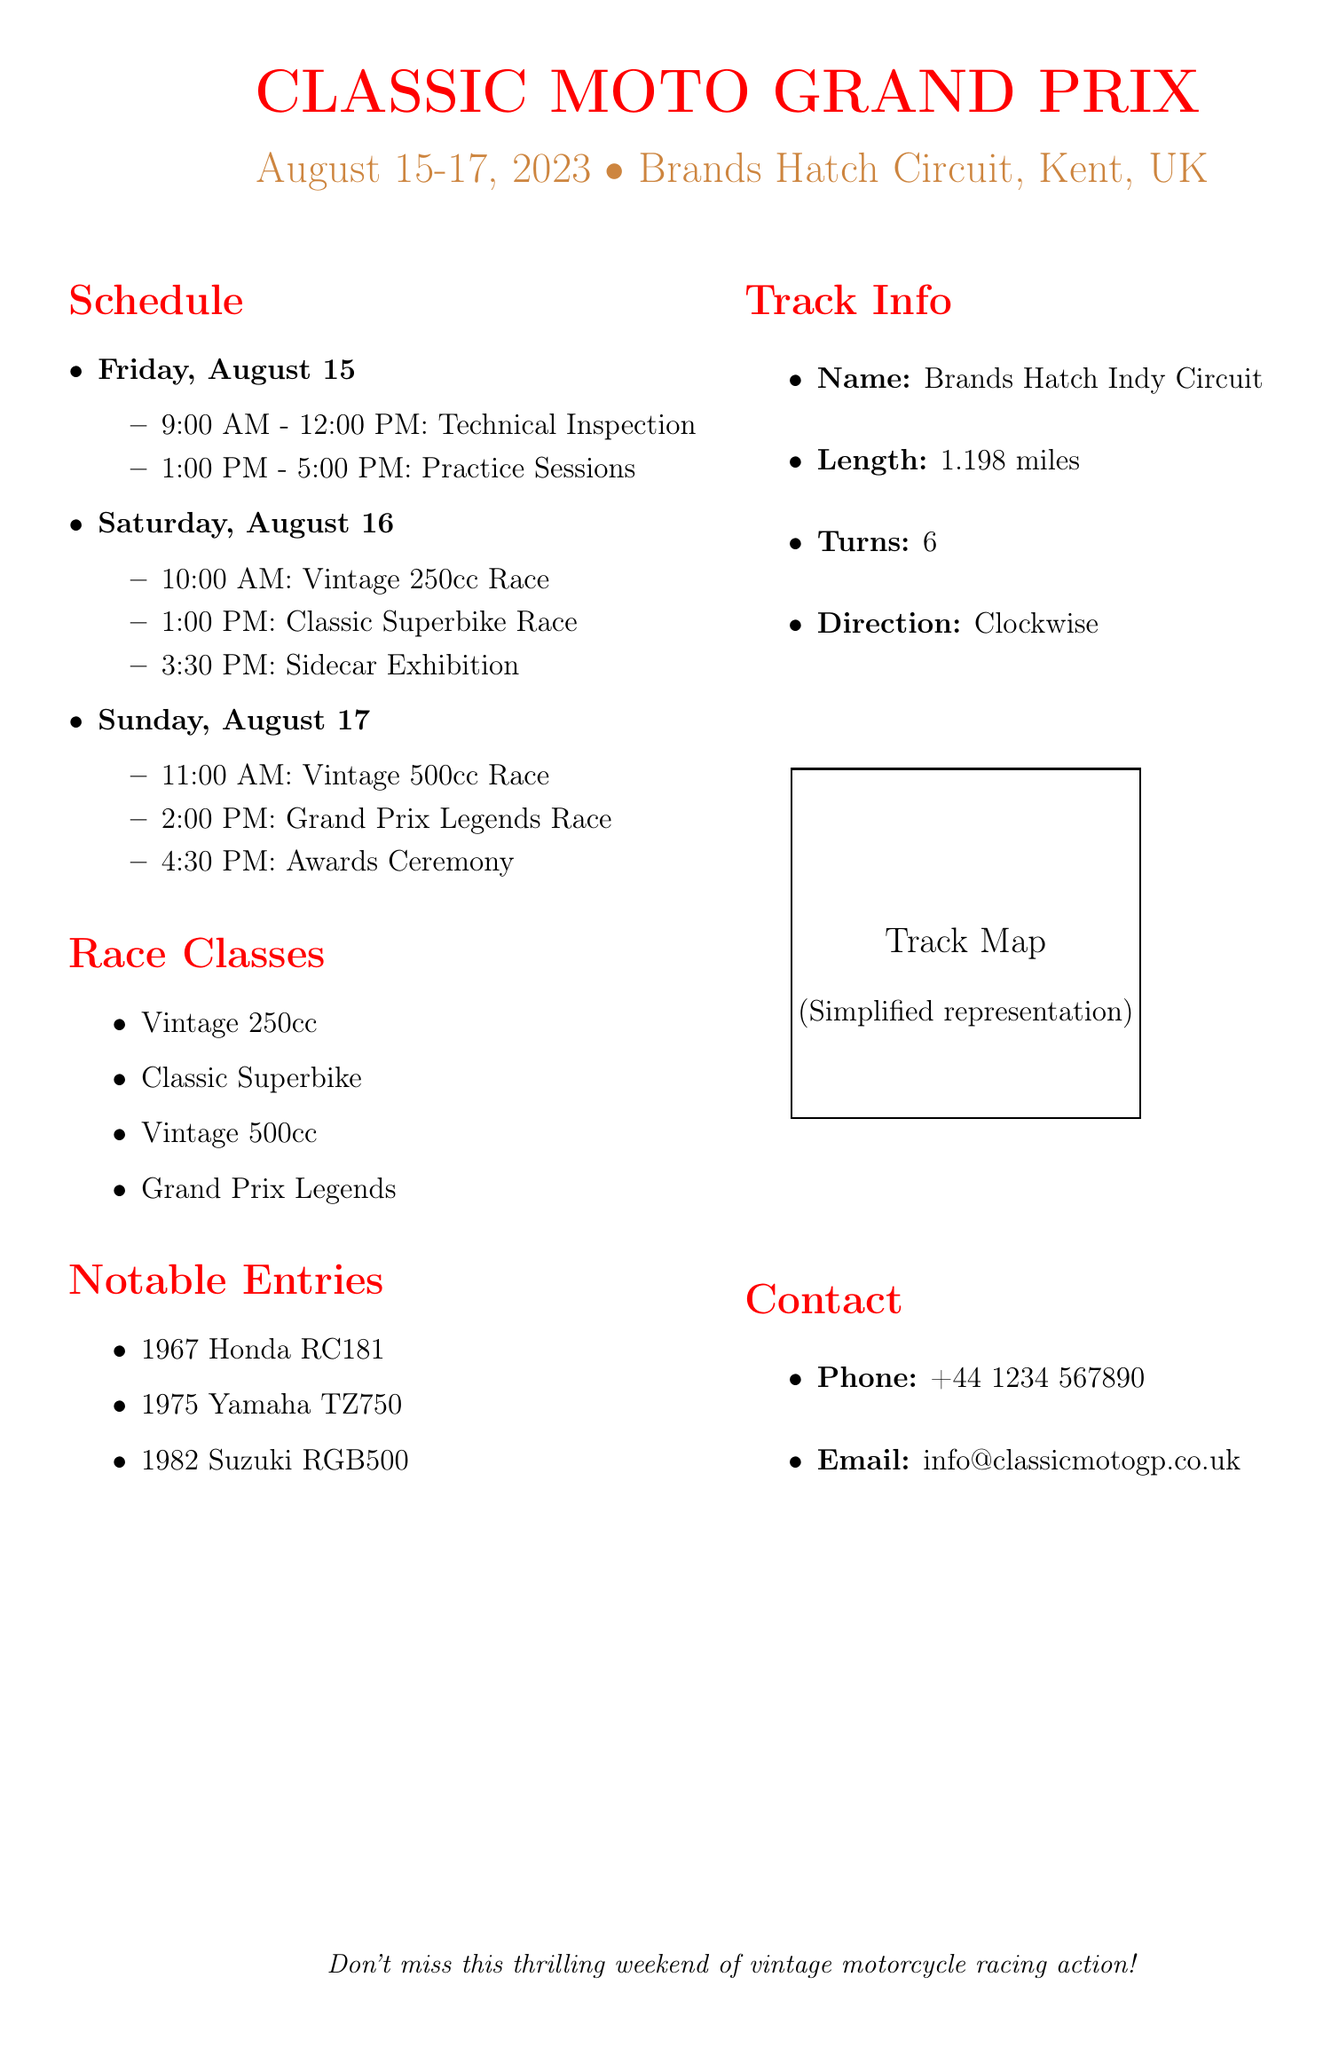What are the dates of the event? The event dates are explicitly stated in the document as August 15-17, 2023.
Answer: August 15-17, 2023 What is the first activity on Friday? According to the schedule, the first activity on Friday is Technical Inspection starting at 9:00 AM.
Answer: Technical Inspection How many races are there on Saturday? The document lists three races on Saturday, making it clear that this is the count of races scheduled for that day.
Answer: 3 What is the length of the track? The document specifies the length of the Brands Hatch Indy Circuit as 1.198 miles.
Answer: 1.198 miles What is the last event of the weekend? The final event mentioned in the schedule is the Awards Ceremony, which takes place on Sunday at 4:30 PM.
Answer: Awards Ceremony How many race classes are listed? The document clearly enumerates four distinct race classes, summarizing the total count of classes available at the event.
Answer: 4 What time does the Vintage 500cc Race start? The schedule clearly states that the Vintage 500cc Race begins at 11:00 AM on Sunday.
Answer: 11:00 AM Which class has a race scheduled first on Saturday? The document outlines that the Vintage 250cc Race is the first race scheduled on Saturday at 10:00 AM.
Answer: Vintage 250cc Race What is the direction of the track? The document mentions that the direction of the Brands Hatch Indy Circuit is clockwise, noting how the races will proceed.
Answer: Clockwise 